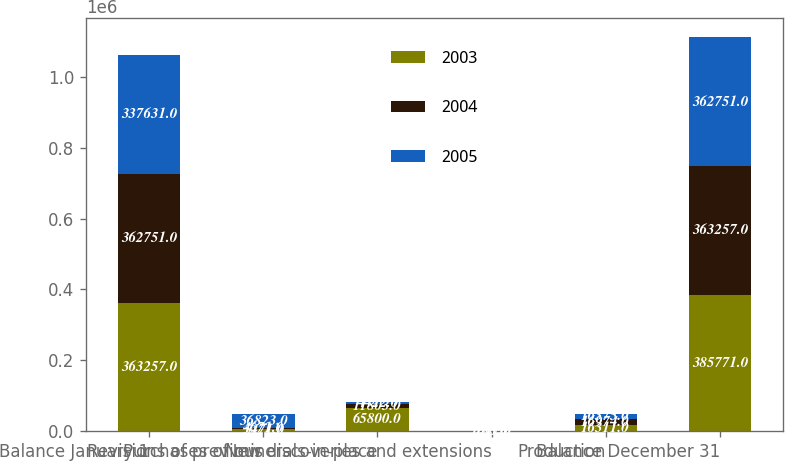Convert chart to OTSL. <chart><loc_0><loc_0><loc_500><loc_500><stacked_bar_chart><ecel><fcel>Balance January 1<fcel>Revisions of previous<fcel>Purchases of minerals-in-place<fcel>New discoveries and extensions<fcel>Production<fcel>Balance December 31<nl><fcel>2003<fcel>363257<fcel>5471<fcel>65800<fcel>225<fcel>16311<fcel>385771<nl><fcel>2004<fcel>362751<fcel>4671<fcel>11803<fcel>1017<fcel>16974<fcel>363257<nl><fcel>2005<fcel>337631<fcel>36823<fcel>4422<fcel>250<fcel>16375<fcel>362751<nl></chart> 